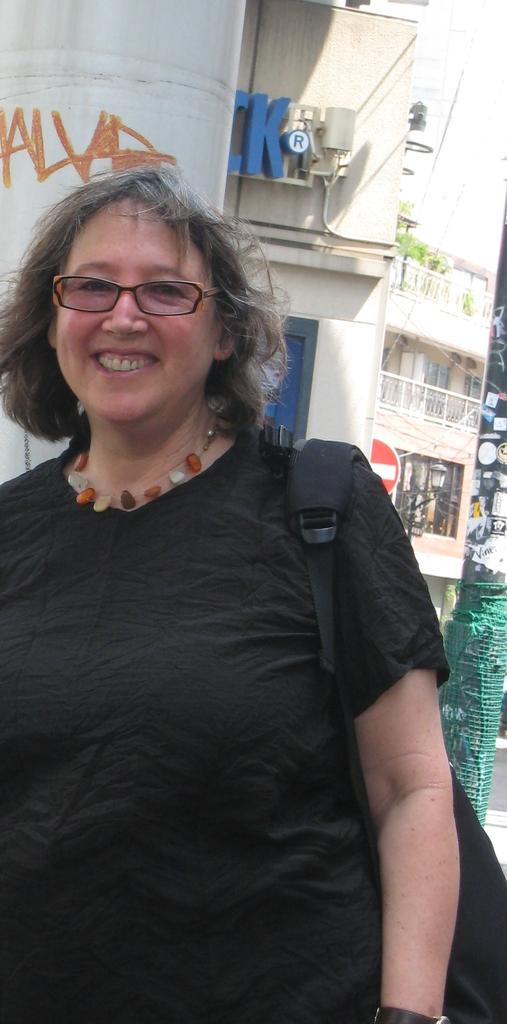Who is present in the image? There is a woman in the image. What is the woman's facial expression? The woman is smiling. What accessories is the woman wearing? The woman is wearing a bag and spectacles. What can be seen in the background of the image? There are buildings and plants in the background of the image. What hobbies does the woman engage in while in her bedroom in the image? The image does not show the woman engaging in any hobbies or indicate that she is in a bedroom. 